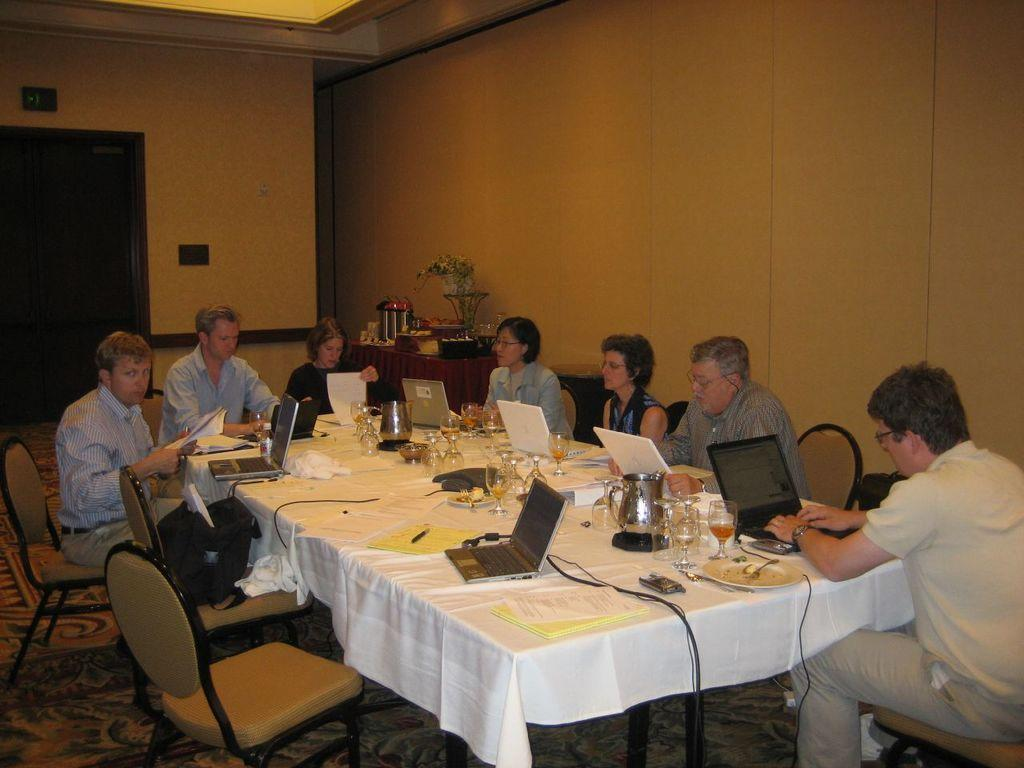What are the people in the image doing? There is a group of people sitting in chairs. What is in front of the group of people? There is a table in front of the group of people. What items can be seen on the table? The table consists of laptops, laptops, books, pens, glasses, and juice. What is the color of the background in the image? The background color is gold. Can you tell me how many people are jumping in the image? There is no one jumping in the image; the people are sitting in chairs. What type of stew is being served on the table in the image? There is no stew present in the image; the table consists of laptops, books, pens, glasses, and juice. 